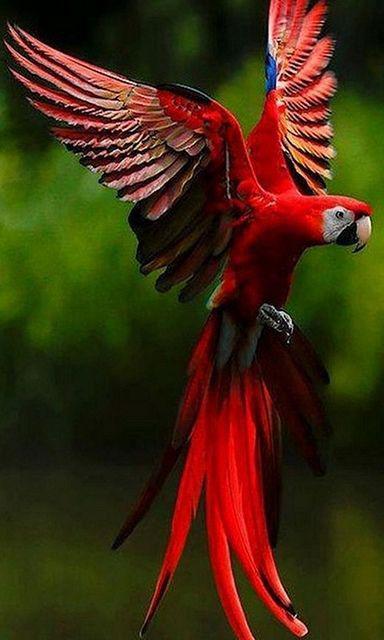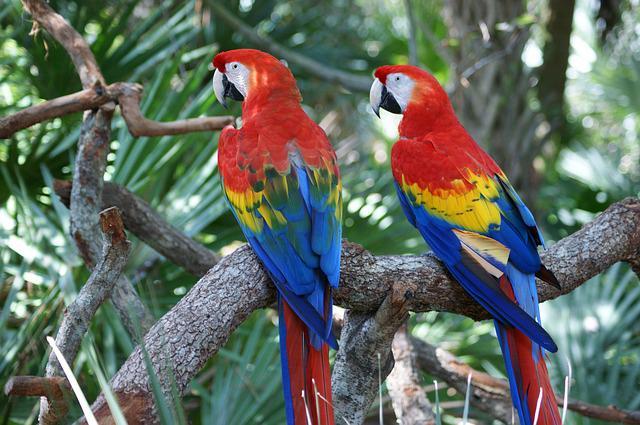The first image is the image on the left, the second image is the image on the right. Considering the images on both sides, is "There are no less than four birds" valid? Answer yes or no. No. The first image is the image on the left, the second image is the image on the right. Assess this claim about the two images: "The right and left images contain the same number of parrots.". Correct or not? Answer yes or no. No. 